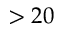<formula> <loc_0><loc_0><loc_500><loc_500>> 2 0</formula> 